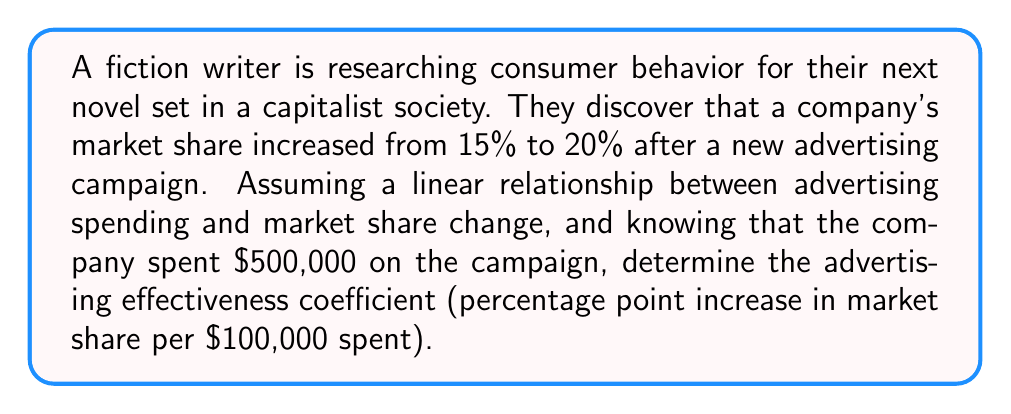Teach me how to tackle this problem. Let's approach this step-by-step:

1. Define the variables:
   $x$ = advertising spending in $100,000 units
   $y$ = market share percentage point increase

2. Calculate the market share increase:
   $y = 20\% - 15\% = 5$ percentage points

3. Convert the advertising spend to $100,000 units:
   $x = \frac{500,000}{100,000} = 5$ units

4. Assuming a linear relationship, we can use the equation:
   $y = mx$
   Where $m$ is the advertising effectiveness coefficient we're looking for.

5. Substitute the known values:
   $5 = m \cdot 5$

6. Solve for $m$:
   $m = \frac{5}{5} = 1$

Therefore, the advertising effectiveness coefficient is 1 percentage point increase in market share per $100,000 spent.
Answer: 1 percentage point/$100,000 